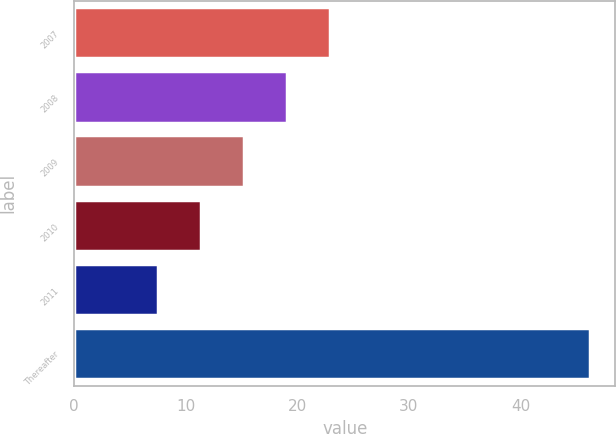<chart> <loc_0><loc_0><loc_500><loc_500><bar_chart><fcel>2007<fcel>2008<fcel>2009<fcel>2010<fcel>2011<fcel>Thereafter<nl><fcel>22.98<fcel>19.11<fcel>15.24<fcel>11.37<fcel>7.5<fcel>46.2<nl></chart> 